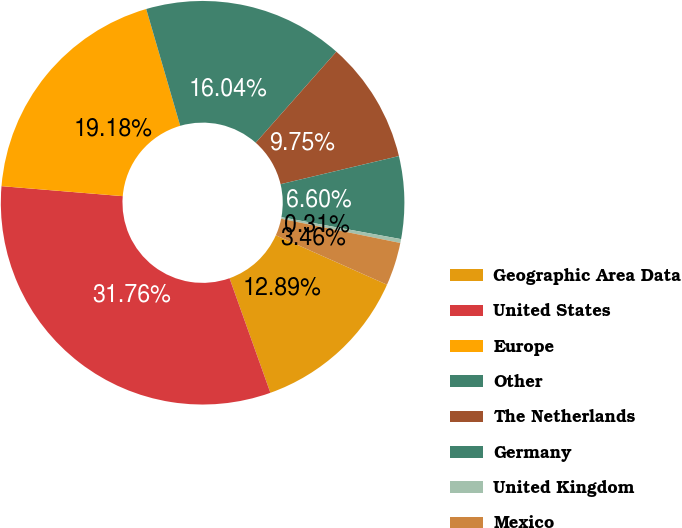Convert chart to OTSL. <chart><loc_0><loc_0><loc_500><loc_500><pie_chart><fcel>Geographic Area Data<fcel>United States<fcel>Europe<fcel>Other<fcel>The Netherlands<fcel>Germany<fcel>United Kingdom<fcel>Mexico<nl><fcel>12.89%<fcel>31.76%<fcel>19.18%<fcel>16.04%<fcel>9.75%<fcel>6.6%<fcel>0.31%<fcel>3.46%<nl></chart> 